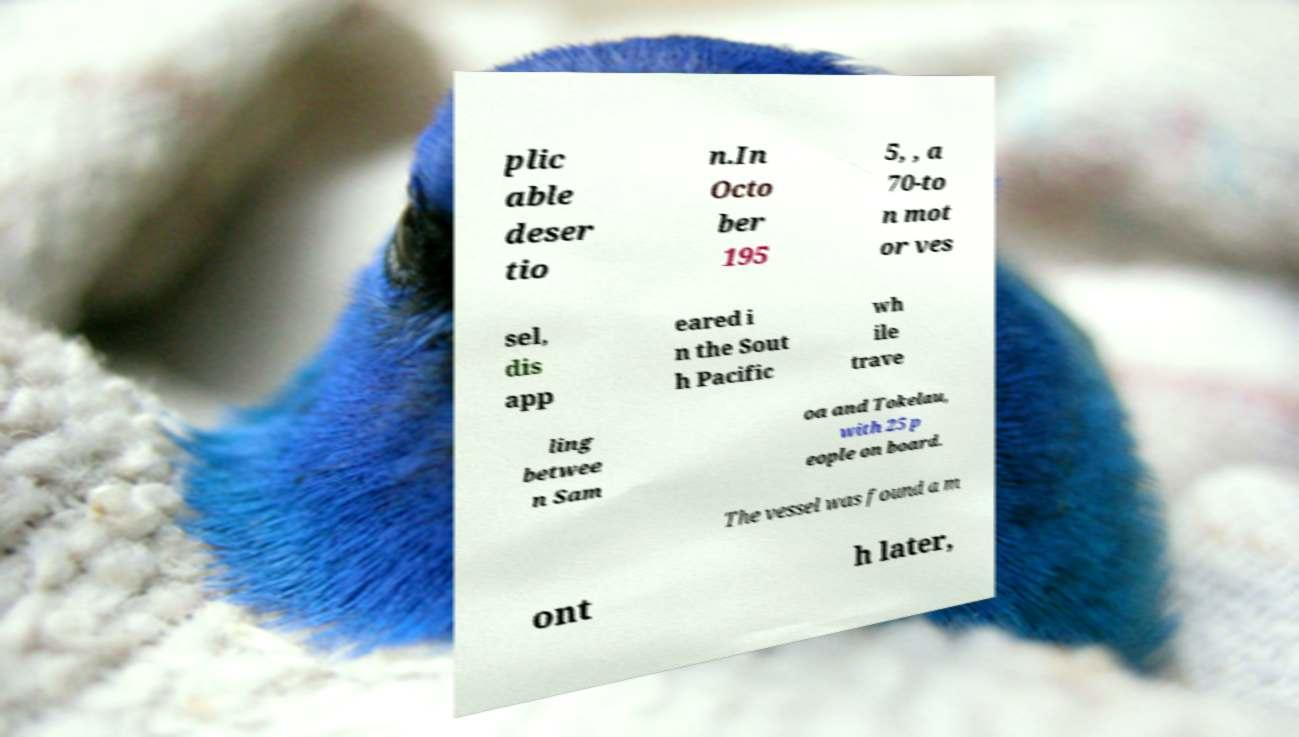Can you read and provide the text displayed in the image?This photo seems to have some interesting text. Can you extract and type it out for me? plic able deser tio n.In Octo ber 195 5, , a 70-to n mot or ves sel, dis app eared i n the Sout h Pacific wh ile trave ling betwee n Sam oa and Tokelau, with 25 p eople on board. The vessel was found a m ont h later, 